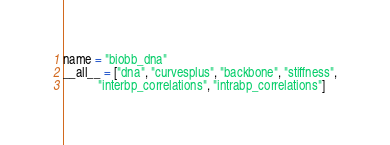<code> <loc_0><loc_0><loc_500><loc_500><_Python_>name = "biobb_dna"
__all__ = ["dna", "curvesplus", "backbone", "stiffness",
           "interbp_correlations", "intrabp_correlations"]
</code> 